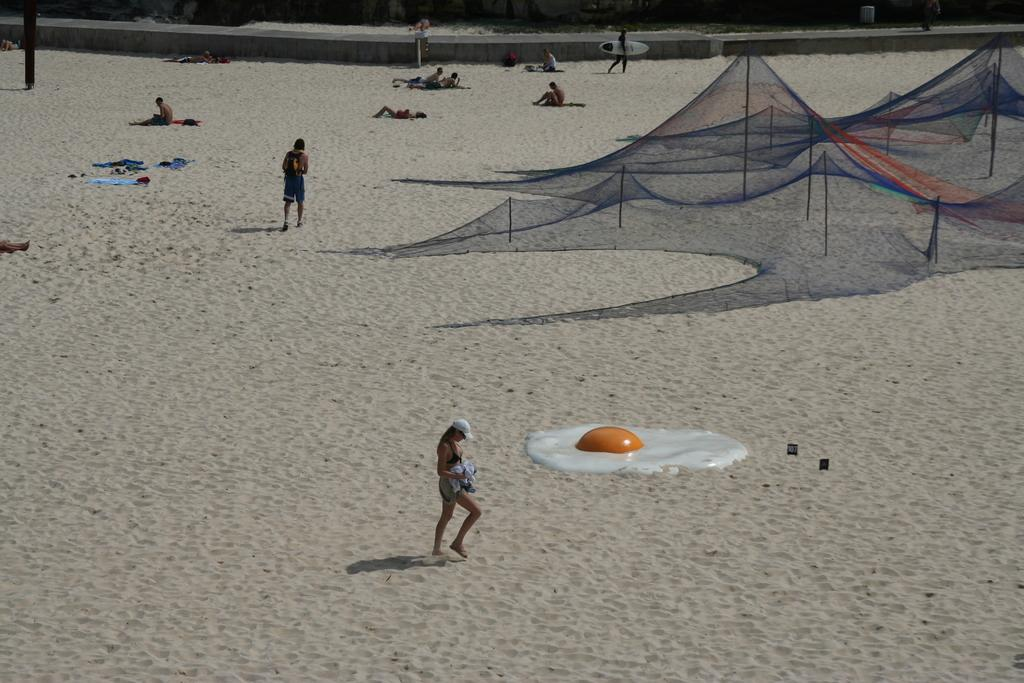What are the people in the image doing? Some people are sitting, some are lying on the ground, and some are standing. Can you describe the positions of the people in the image? Yes, some people are sitting, some are lying on the ground, and some are standing. What is the white and orange object in the image? Unfortunately, the facts provided do not give any information about the white and orange object. What type of garden can be seen in the background of the image? There is no garden present in the image. 